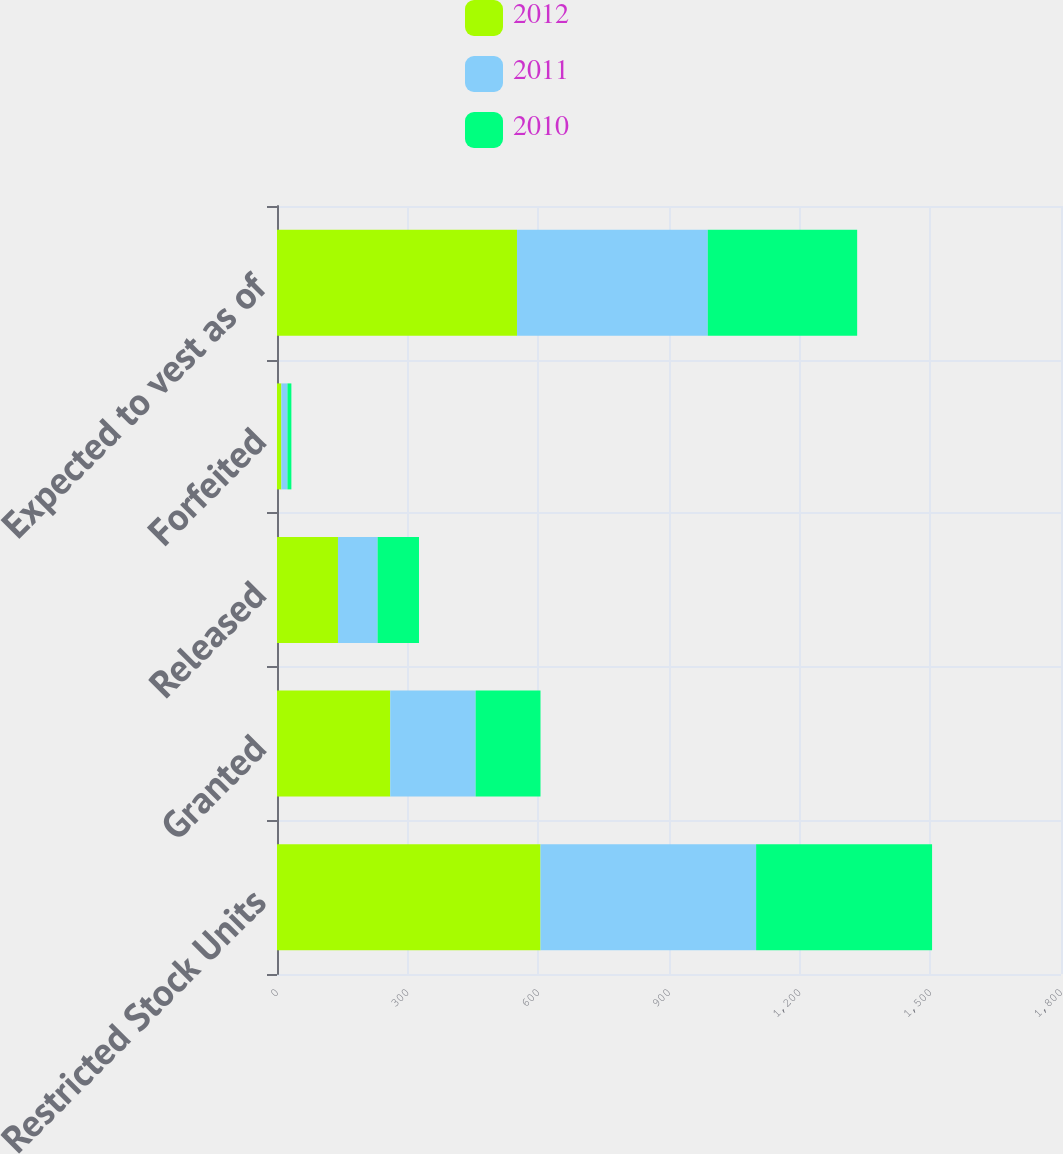Convert chart to OTSL. <chart><loc_0><loc_0><loc_500><loc_500><stacked_bar_chart><ecel><fcel>Restricted Stock Units<fcel>Granted<fcel>Released<fcel>Forfeited<fcel>Expected to vest as of<nl><fcel>2012<fcel>605<fcel>260<fcel>140<fcel>10<fcel>551<nl><fcel>2011<fcel>495<fcel>196<fcel>91<fcel>14<fcel>438<nl><fcel>2010<fcel>404<fcel>149<fcel>95<fcel>9<fcel>343<nl></chart> 